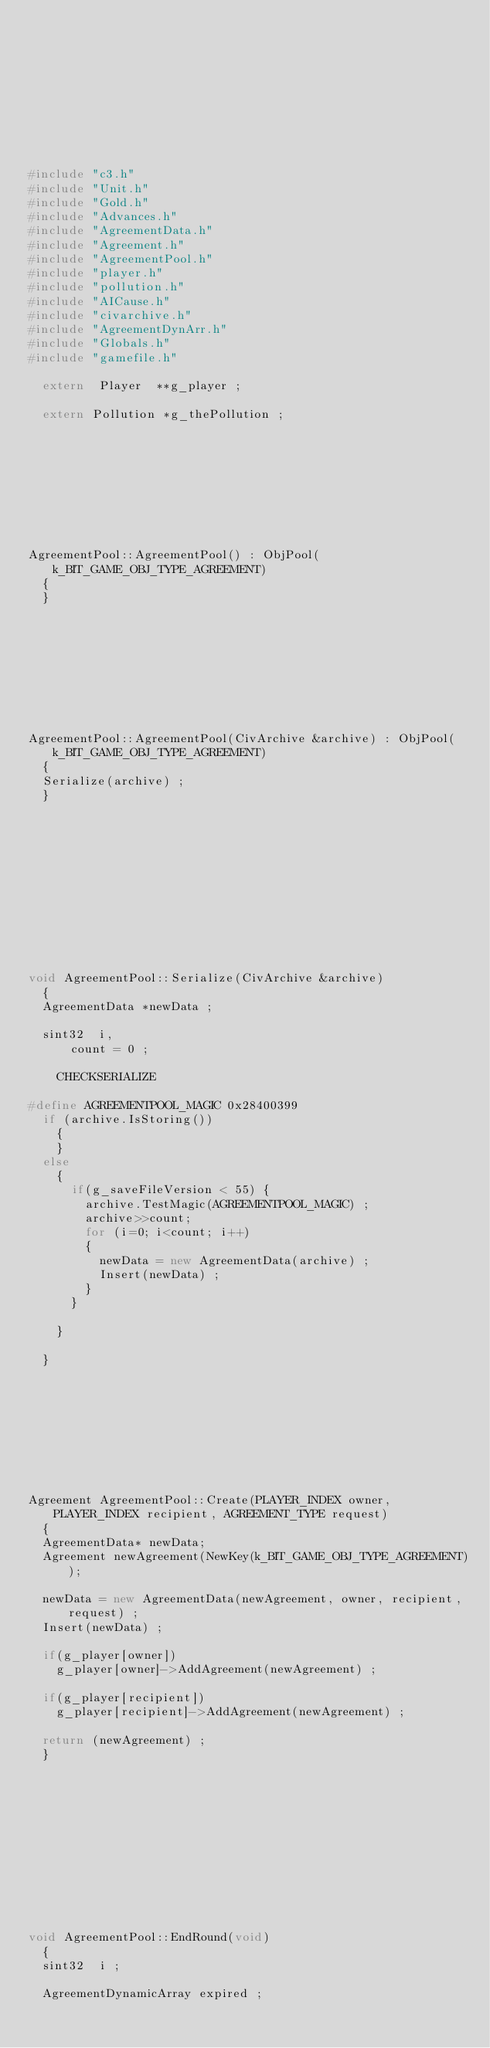Convert code to text. <code><loc_0><loc_0><loc_500><loc_500><_C++_>









#include "c3.h"
#include "Unit.h"
#include "Gold.h"
#include "Advances.h"
#include "AgreementData.h"
#include "Agreement.h"
#include "AgreementPool.h"
#include "player.h"
#include "pollution.h"
#include "AICause.h"
#include "civarchive.h"
#include "AgreementDynArr.h"
#include "Globals.h"
#include "gamefile.h"
	
	extern	Player	**g_player ;

	extern Pollution *g_thePollution ;









AgreementPool::AgreementPool() : ObjPool(k_BIT_GAME_OBJ_TYPE_AGREEMENT)
	{
	}









AgreementPool::AgreementPool(CivArchive &archive) : ObjPool(k_BIT_GAME_OBJ_TYPE_AGREEMENT)
	{
	Serialize(archive) ;
	}












void AgreementPool::Serialize(CivArchive &archive)
	{
	AgreementData	*newData ;

	sint32	i,
			count = 0 ;

    CHECKSERIALIZE

#define AGREEMENTPOOL_MAGIC 0x28400399
	if (archive.IsStoring())
		{
		}
	else
		{
			if(g_saveFileVersion < 55) {
				archive.TestMagic(AGREEMENTPOOL_MAGIC) ;
				archive>>count;
				for (i=0; i<count; i++)
				{
					newData = new AgreementData(archive) ;
					Insert(newData) ;
				}
			}

		}

	}
	
	







Agreement AgreementPool::Create(PLAYER_INDEX owner, PLAYER_INDEX recipient, AGREEMENT_TYPE request)
	{
	AgreementData* newData;
	Agreement newAgreement(NewKey(k_BIT_GAME_OBJ_TYPE_AGREEMENT));
	
	newData = new AgreementData(newAgreement, owner, recipient, request) ;
	Insert(newData) ;

	if(g_player[owner])
		g_player[owner]->AddAgreement(newAgreement) ;					

	if(g_player[recipient])
		g_player[recipient]->AddAgreement(newAgreement) ;				

	return (newAgreement) ;
	}












void AgreementPool::EndRound(void)
	{
	sint32	i ;

	AgreementDynamicArray	expired ;
</code> 